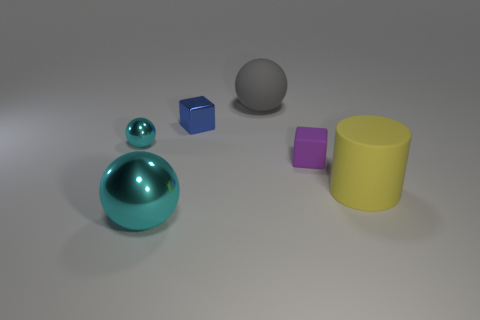Subtract all gray spheres. How many spheres are left? 2 Add 4 large red rubber spheres. How many objects exist? 10 Subtract 1 balls. How many balls are left? 2 Subtract all yellow cylinders. How many cyan spheres are left? 2 Subtract all cylinders. How many objects are left? 5 Add 4 large metal balls. How many large metal balls are left? 5 Add 3 tiny rubber cubes. How many tiny rubber cubes exist? 4 Subtract 0 brown cylinders. How many objects are left? 6 Subtract all red cubes. Subtract all red balls. How many cubes are left? 2 Subtract all blue blocks. Subtract all blue metallic blocks. How many objects are left? 4 